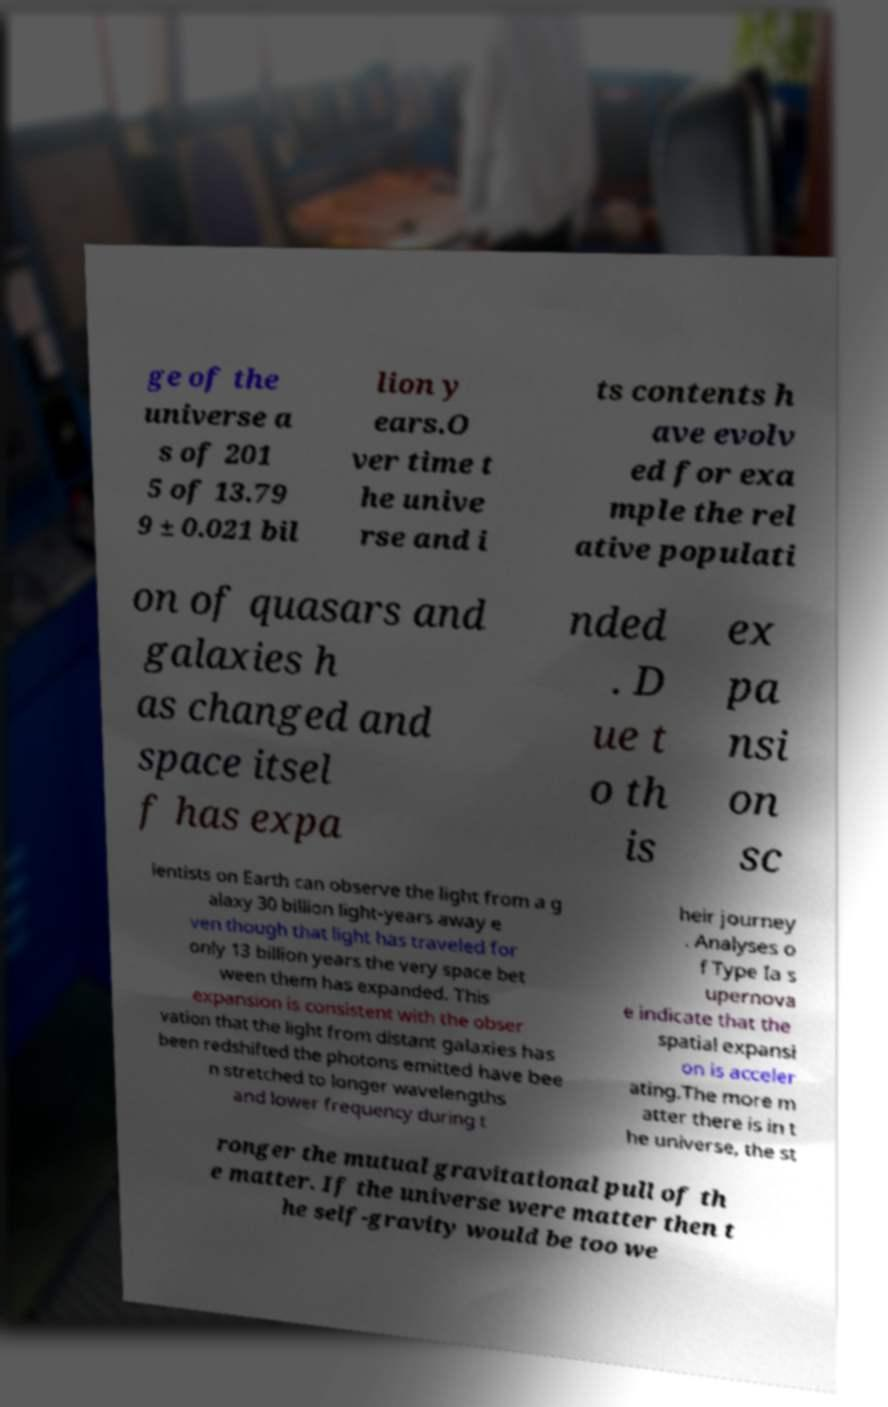Could you extract and type out the text from this image? ge of the universe a s of 201 5 of 13.79 9 ± 0.021 bil lion y ears.O ver time t he unive rse and i ts contents h ave evolv ed for exa mple the rel ative populati on of quasars and galaxies h as changed and space itsel f has expa nded . D ue t o th is ex pa nsi on sc ientists on Earth can observe the light from a g alaxy 30 billion light-years away e ven though that light has traveled for only 13 billion years the very space bet ween them has expanded. This expansion is consistent with the obser vation that the light from distant galaxies has been redshifted the photons emitted have bee n stretched to longer wavelengths and lower frequency during t heir journey . Analyses o f Type Ia s upernova e indicate that the spatial expansi on is acceler ating.The more m atter there is in t he universe, the st ronger the mutual gravitational pull of th e matter. If the universe were matter then t he self-gravity would be too we 